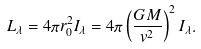<formula> <loc_0><loc_0><loc_500><loc_500>L _ { \lambda } = 4 \pi r _ { 0 } ^ { 2 } I _ { \lambda } = 4 \pi \left ( \frac { G M } { v ^ { 2 } } \right ) ^ { 2 } I _ { \lambda } .</formula> 